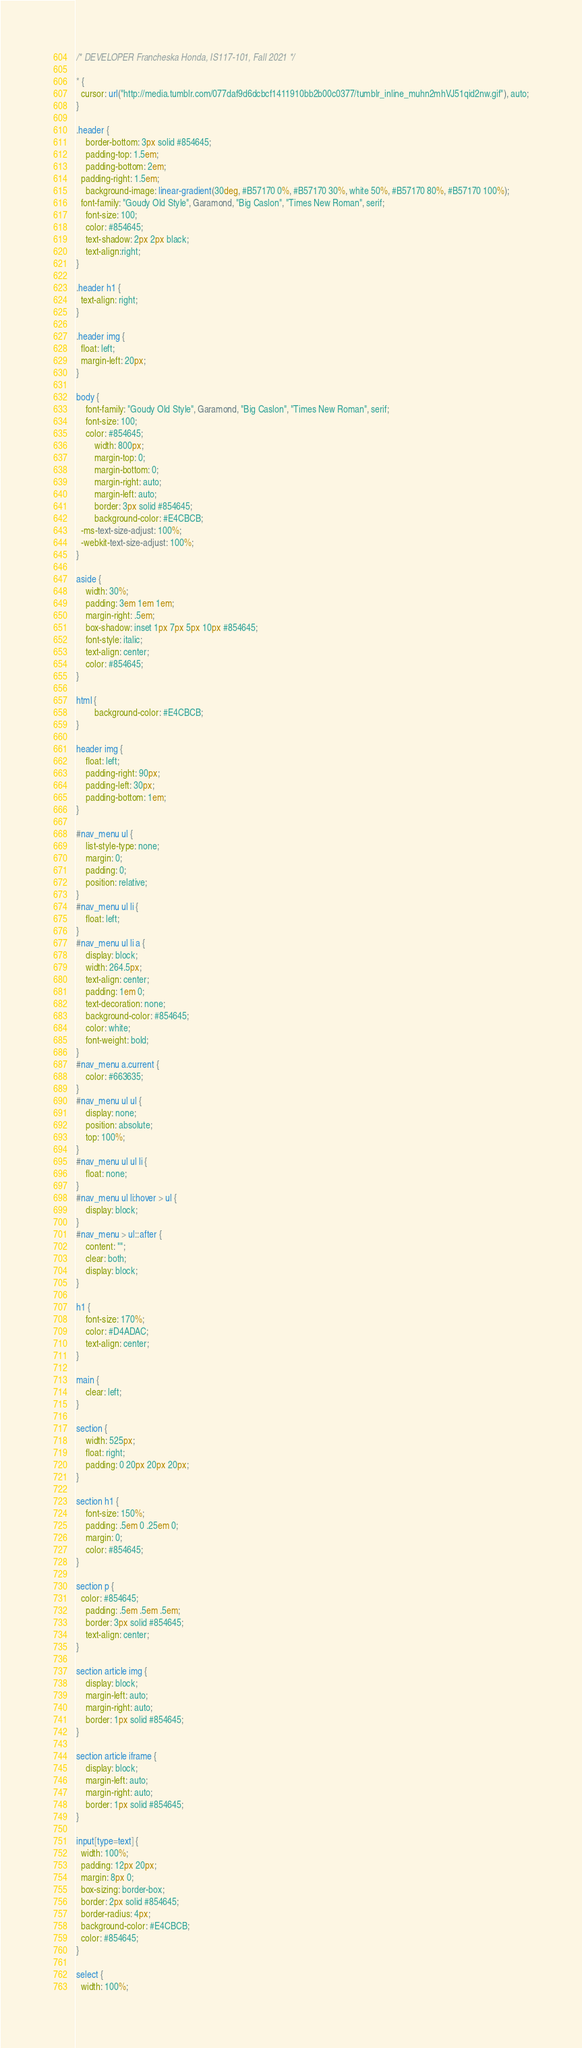Convert code to text. <code><loc_0><loc_0><loc_500><loc_500><_CSS_>/* DEVELOPER Francheska Honda, IS117-101, Fall 2021 */

* {
  cursor: url("http://media.tumblr.com/077daf9d6dcbcf1411910bb2b00c0377/tumblr_inline_muhn2mhVJ51qid2nw.gif"), auto;
}

.header {
	border-bottom: 3px solid #854645;
	padding-top: 1.5em;
	padding-bottom: 2em;
  padding-right: 1.5em;
	background-image: linear-gradient(30deg, #B57170 0%, #B57170 30%, white 50%, #B57170 80%, #B57170 100%);
  font-family: "Goudy Old Style", Garamond, "Big Caslon", "Times New Roman", serif;
    font-size: 100;
    color: #854645;
    text-shadow: 2px 2px black;
    text-align:right;
}

.header h1 {
  text-align: right;
}

.header img {
  float: left;
  margin-left: 20px;
}

body {
	font-family: "Goudy Old Style", Garamond, "Big Caslon", "Times New Roman", serif;
    font-size: 100;
    color: #854645;
		width: 800px;
		margin-top: 0;
		margin-bottom: 0;
		margin-right: auto;
		margin-left: auto;
		border: 3px solid #854645;
		background-color: #E4CBCB;
  -ms-text-size-adjust: 100%;
  -webkit-text-size-adjust: 100%;
}

aside {
	width: 30%;
	padding: 3em 1em 1em;
	margin-right: .5em;
	box-shadow: inset 1px 7px 5px 10px #854645;
	font-style: italic;
	text-align: center;
	color: #854645;
}

html {
		background-color: #E4CBCB;
}

header img {
	float: left;
	padding-right: 90px;
	padding-left: 30px;
	padding-bottom: 1em;
}

#nav_menu ul {
	list-style-type: none;
	margin: 0;
	padding: 0;
	position: relative;
}
#nav_menu ul li {
	float: left;
}
#nav_menu ul li a {
    display: block;
    width: 264.5px;
    text-align: center;
    padding: 1em 0;
    text-decoration: none;
    background-color: #854645;
    color: white;
    font-weight: bold;
}
#nav_menu a.current {
	color: #663635;
}
#nav_menu ul ul {
    display: none;
    position: absolute;
    top: 100%;
}
#nav_menu ul ul li {
	float: none;
}
#nav_menu ul li:hover > ul {
	display: block;
}
#nav_menu > ul::after {
    content: "";
    clear: both;
    display: block;
}

h1 {
	font-size: 170%;
	color: #D4ADAC;
	text-align: center;
}

main {
	clear: left;
}

section {
	width: 525px;
	float: right;
	padding: 0 20px 20px 20px;
}

section h1 {
	font-size: 150%;
	padding: .5em 0 .25em 0;
	margin: 0;
	color: #854645;
}

section p {
  color: #854645;
	padding: .5em .5em .5em;
	border: 3px solid #854645;
	text-align: center;
}

section article img {
	display: block;
	margin-left: auto;
	margin-right: auto;
	border: 1px solid #854645;
}

section article iframe {
	display: block;
	margin-left: auto;
	margin-right: auto;
	border: 1px solid #854645;
}

input[type=text] {
  width: 100%;
  padding: 12px 20px;
  margin: 8px 0;
  box-sizing: border-box;
  border: 2px solid #854645;
  border-radius: 4px;
  background-color: #E4CBCB;
  color: #854645;
}

select {
  width: 100%;</code> 